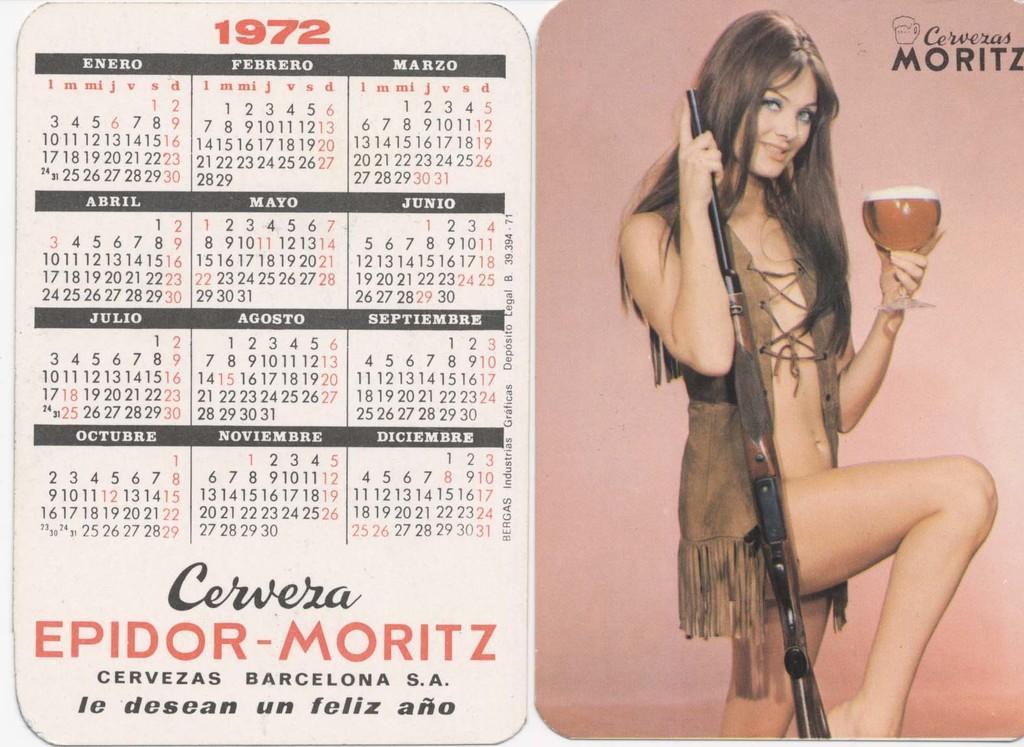How would you summarize this image in a sentence or two? It is a collage image with calendar. Beside the calendar there is a picture of a woman holding the gun and a glass. There is some text on the top right of the image. 